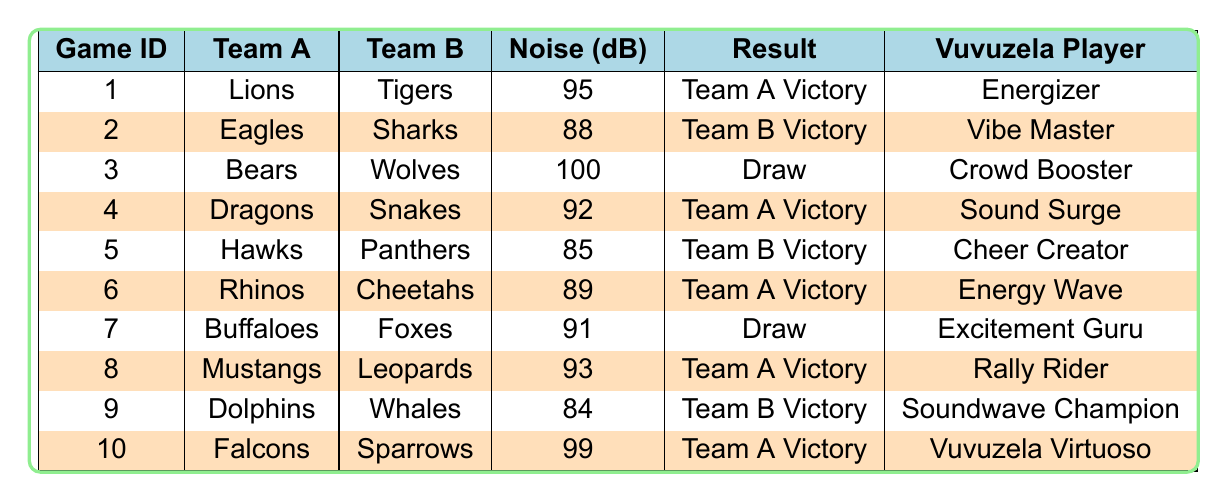What was the highest average noise level recorded? The highest average noise level is represented in the table as 100 dB for game ID 3 featuring Bears vs. Wolves. I identified this by referencing the 'Noise (dB)' column and finding the maximum value.
Answer: 100 dB Which team played in game ID 6? The teams listed for game ID 6 are Rhinos and Cheetahs. This information can be found in the corresponding row of the table under the 'Team A' and 'Team B' columns.
Answer: Rhinos and Cheetahs How many games resulted in a draw? There are two games that resulted in a draw. Specifically, game IDs 3 and 7 had the result "Draw." I counted the occurrences of the word "Draw" in the 'Result' column.
Answer: 2 What is the average noise level of games resulting in Team A victories? For the games that resulted in Team A victories (game IDs 1, 4, 6, 8, and 10), the average noise level is calculated by summing the corresponding noise levels (95 + 92 + 89 + 93 + 99 = 468) and dividing by the number of victories (5). This yields an average of 93.6 dB, rounded to one decimal place.
Answer: 93.6 dB Did Team B win any games with an average noise level above 90 dB? Yes, Team B won one game with an average noise level above 90 dB. This occurs in game ID 2 with an average of 88 dB and game ID 9 with an average of 84 dB, both of which do not meet the criteria, hence the answer is "No."
Answer: No How many games had vuvuzela players named "Energizer," "Energy Wave," or "Vibe Master"? Three games featured these specific vuvuzela players. By checking the 'Vuvuzela Player' column, I found that Energizer (game ID 1), Energy Wave (game ID 6), and Vibe Master (game ID 2) all match the criteria. I counted these instances.
Answer: 3 